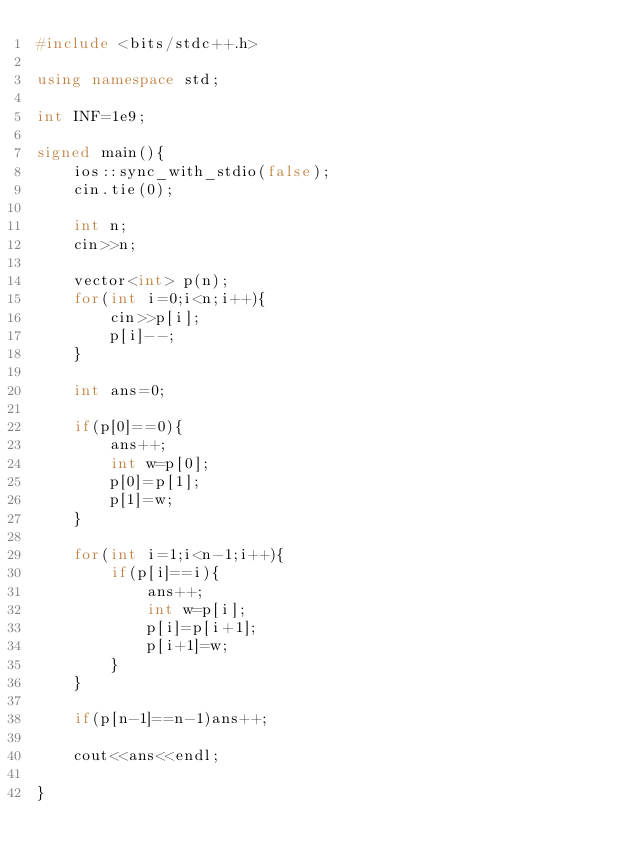<code> <loc_0><loc_0><loc_500><loc_500><_C++_>#include <bits/stdc++.h>

using namespace std;

int INF=1e9;

signed main(){
    ios::sync_with_stdio(false);
    cin.tie(0);

    int n;
    cin>>n;

    vector<int> p(n);
    for(int i=0;i<n;i++){
        cin>>p[i];
        p[i]--;
    }

    int ans=0;

    if(p[0]==0){
        ans++;
        int w=p[0];
        p[0]=p[1];
        p[1]=w;
    }

    for(int i=1;i<n-1;i++){
        if(p[i]==i){
            ans++;
            int w=p[i];
            p[i]=p[i+1];
            p[i+1]=w;
        }
    }

    if(p[n-1]==n-1)ans++;

    cout<<ans<<endl;

}</code> 